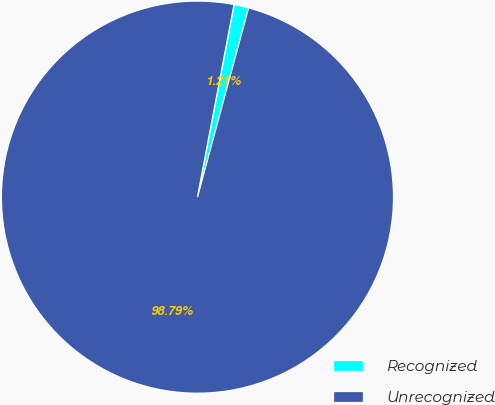Convert chart. <chart><loc_0><loc_0><loc_500><loc_500><pie_chart><fcel>Recognized<fcel>Unrecognized<nl><fcel>1.21%<fcel>98.79%<nl></chart> 